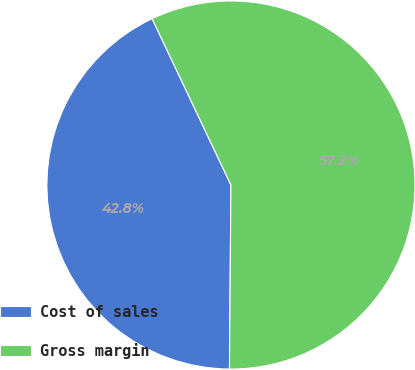<chart> <loc_0><loc_0><loc_500><loc_500><pie_chart><fcel>Cost of sales<fcel>Gross margin<nl><fcel>42.83%<fcel>57.17%<nl></chart> 